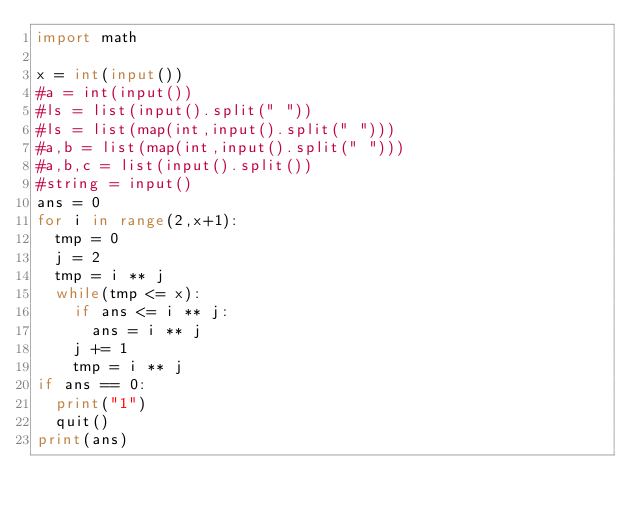<code> <loc_0><loc_0><loc_500><loc_500><_Python_>import math

x = int(input())
#a = int(input())
#ls = list(input().split(" "))
#ls = list(map(int,input().split(" ")))
#a,b = list(map(int,input().split(" ")))
#a,b,c = list(input().split())
#string = input()
ans = 0
for i in range(2,x+1):
  tmp = 0
  j = 2
  tmp = i ** j
  while(tmp <= x):
    if ans <= i ** j:
      ans = i ** j
    j += 1
    tmp = i ** j
if ans == 0:
  print("1")
  quit()
print(ans)</code> 